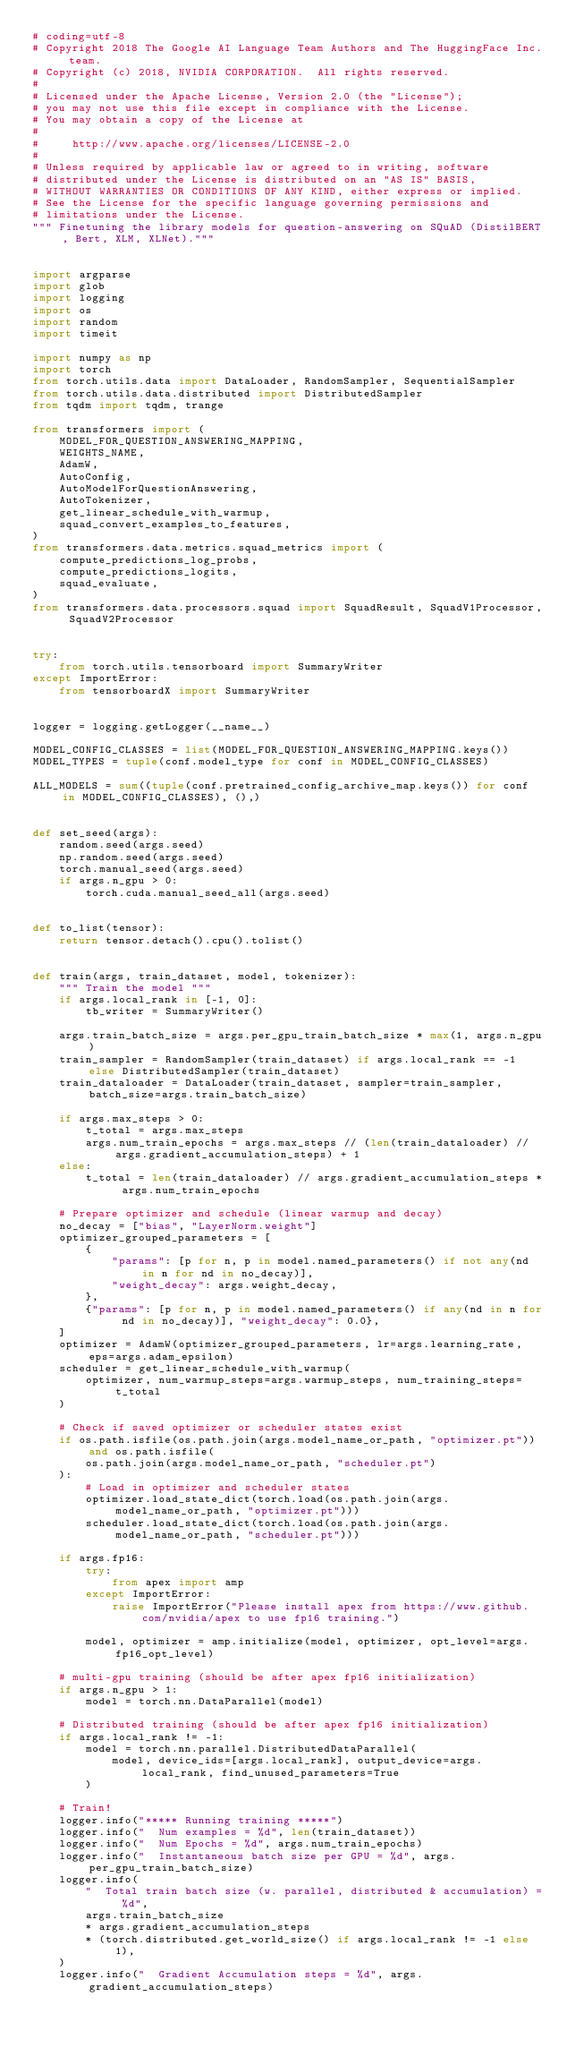Convert code to text. <code><loc_0><loc_0><loc_500><loc_500><_Python_># coding=utf-8
# Copyright 2018 The Google AI Language Team Authors and The HuggingFace Inc. team.
# Copyright (c) 2018, NVIDIA CORPORATION.  All rights reserved.
#
# Licensed under the Apache License, Version 2.0 (the "License");
# you may not use this file except in compliance with the License.
# You may obtain a copy of the License at
#
#     http://www.apache.org/licenses/LICENSE-2.0
#
# Unless required by applicable law or agreed to in writing, software
# distributed under the License is distributed on an "AS IS" BASIS,
# WITHOUT WARRANTIES OR CONDITIONS OF ANY KIND, either express or implied.
# See the License for the specific language governing permissions and
# limitations under the License.
""" Finetuning the library models for question-answering on SQuAD (DistilBERT, Bert, XLM, XLNet)."""


import argparse
import glob
import logging
import os
import random
import timeit

import numpy as np
import torch
from torch.utils.data import DataLoader, RandomSampler, SequentialSampler
from torch.utils.data.distributed import DistributedSampler
from tqdm import tqdm, trange

from transformers import (
    MODEL_FOR_QUESTION_ANSWERING_MAPPING,
    WEIGHTS_NAME,
    AdamW,
    AutoConfig,
    AutoModelForQuestionAnswering,
    AutoTokenizer,
    get_linear_schedule_with_warmup,
    squad_convert_examples_to_features,
)
from transformers.data.metrics.squad_metrics import (
    compute_predictions_log_probs,
    compute_predictions_logits,
    squad_evaluate,
)
from transformers.data.processors.squad import SquadResult, SquadV1Processor, SquadV2Processor


try:
    from torch.utils.tensorboard import SummaryWriter
except ImportError:
    from tensorboardX import SummaryWriter


logger = logging.getLogger(__name__)

MODEL_CONFIG_CLASSES = list(MODEL_FOR_QUESTION_ANSWERING_MAPPING.keys())
MODEL_TYPES = tuple(conf.model_type for conf in MODEL_CONFIG_CLASSES)

ALL_MODELS = sum((tuple(conf.pretrained_config_archive_map.keys()) for conf in MODEL_CONFIG_CLASSES), (),)


def set_seed(args):
    random.seed(args.seed)
    np.random.seed(args.seed)
    torch.manual_seed(args.seed)
    if args.n_gpu > 0:
        torch.cuda.manual_seed_all(args.seed)


def to_list(tensor):
    return tensor.detach().cpu().tolist()


def train(args, train_dataset, model, tokenizer):
    """ Train the model """
    if args.local_rank in [-1, 0]:
        tb_writer = SummaryWriter()

    args.train_batch_size = args.per_gpu_train_batch_size * max(1, args.n_gpu)
    train_sampler = RandomSampler(train_dataset) if args.local_rank == -1 else DistributedSampler(train_dataset)
    train_dataloader = DataLoader(train_dataset, sampler=train_sampler, batch_size=args.train_batch_size)

    if args.max_steps > 0:
        t_total = args.max_steps
        args.num_train_epochs = args.max_steps // (len(train_dataloader) // args.gradient_accumulation_steps) + 1
    else:
        t_total = len(train_dataloader) // args.gradient_accumulation_steps * args.num_train_epochs

    # Prepare optimizer and schedule (linear warmup and decay)
    no_decay = ["bias", "LayerNorm.weight"]
    optimizer_grouped_parameters = [
        {
            "params": [p for n, p in model.named_parameters() if not any(nd in n for nd in no_decay)],
            "weight_decay": args.weight_decay,
        },
        {"params": [p for n, p in model.named_parameters() if any(nd in n for nd in no_decay)], "weight_decay": 0.0},
    ]
    optimizer = AdamW(optimizer_grouped_parameters, lr=args.learning_rate, eps=args.adam_epsilon)
    scheduler = get_linear_schedule_with_warmup(
        optimizer, num_warmup_steps=args.warmup_steps, num_training_steps=t_total
    )

    # Check if saved optimizer or scheduler states exist
    if os.path.isfile(os.path.join(args.model_name_or_path, "optimizer.pt")) and os.path.isfile(
        os.path.join(args.model_name_or_path, "scheduler.pt")
    ):
        # Load in optimizer and scheduler states
        optimizer.load_state_dict(torch.load(os.path.join(args.model_name_or_path, "optimizer.pt")))
        scheduler.load_state_dict(torch.load(os.path.join(args.model_name_or_path, "scheduler.pt")))

    if args.fp16:
        try:
            from apex import amp
        except ImportError:
            raise ImportError("Please install apex from https://www.github.com/nvidia/apex to use fp16 training.")

        model, optimizer = amp.initialize(model, optimizer, opt_level=args.fp16_opt_level)

    # multi-gpu training (should be after apex fp16 initialization)
    if args.n_gpu > 1:
        model = torch.nn.DataParallel(model)

    # Distributed training (should be after apex fp16 initialization)
    if args.local_rank != -1:
        model = torch.nn.parallel.DistributedDataParallel(
            model, device_ids=[args.local_rank], output_device=args.local_rank, find_unused_parameters=True
        )

    # Train!
    logger.info("***** Running training *****")
    logger.info("  Num examples = %d", len(train_dataset))
    logger.info("  Num Epochs = %d", args.num_train_epochs)
    logger.info("  Instantaneous batch size per GPU = %d", args.per_gpu_train_batch_size)
    logger.info(
        "  Total train batch size (w. parallel, distributed & accumulation) = %d",
        args.train_batch_size
        * args.gradient_accumulation_steps
        * (torch.distributed.get_world_size() if args.local_rank != -1 else 1),
    )
    logger.info("  Gradient Accumulation steps = %d", args.gradient_accumulation_steps)</code> 